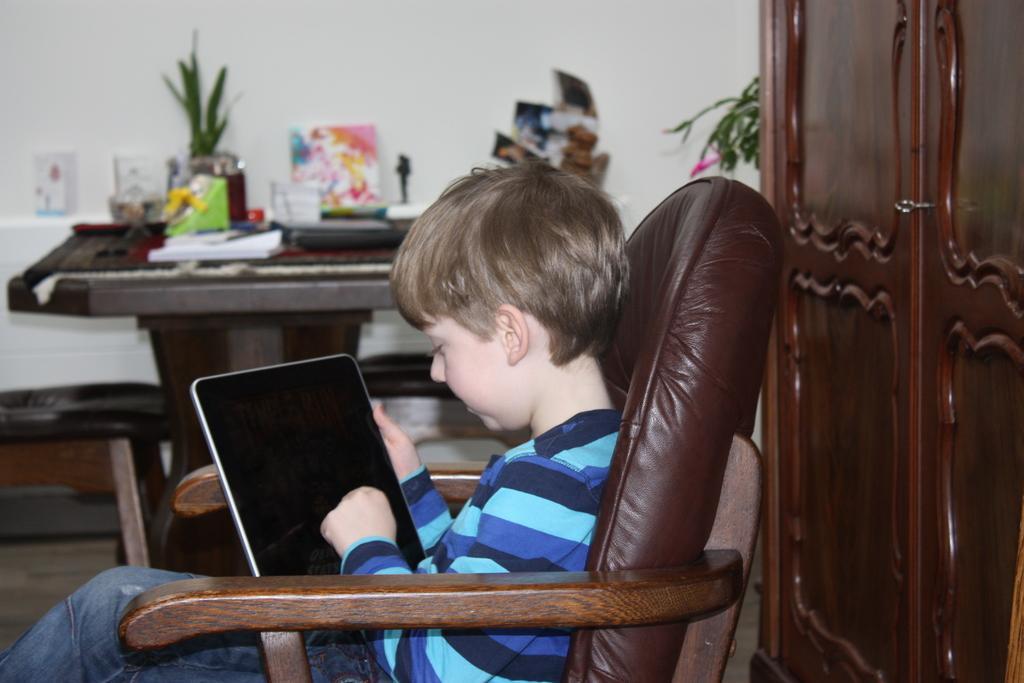Can you describe this image briefly? In this image there is a kid sitting in a chair and using the tablet. At the background there is a wall and a table in front of it on which there are papers,flower vase,toys,painting. At the back side of the kid there is a cupboard. 